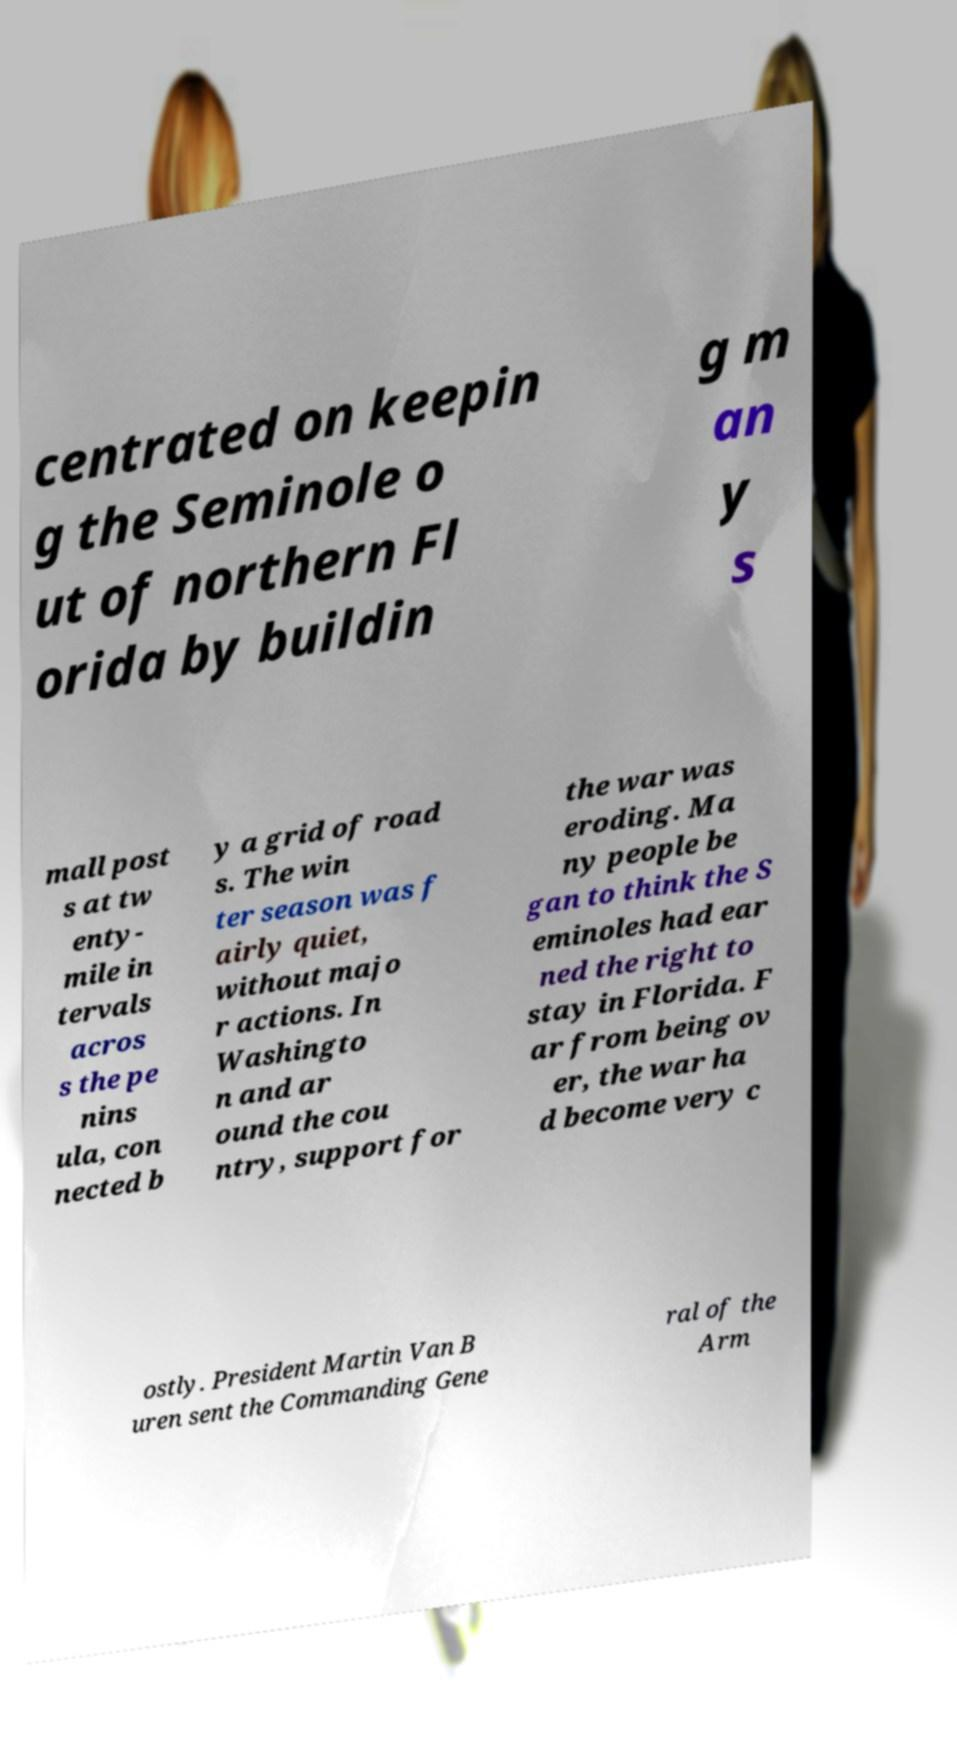For documentation purposes, I need the text within this image transcribed. Could you provide that? centrated on keepin g the Seminole o ut of northern Fl orida by buildin g m an y s mall post s at tw enty- mile in tervals acros s the pe nins ula, con nected b y a grid of road s. The win ter season was f airly quiet, without majo r actions. In Washingto n and ar ound the cou ntry, support for the war was eroding. Ma ny people be gan to think the S eminoles had ear ned the right to stay in Florida. F ar from being ov er, the war ha d become very c ostly. President Martin Van B uren sent the Commanding Gene ral of the Arm 